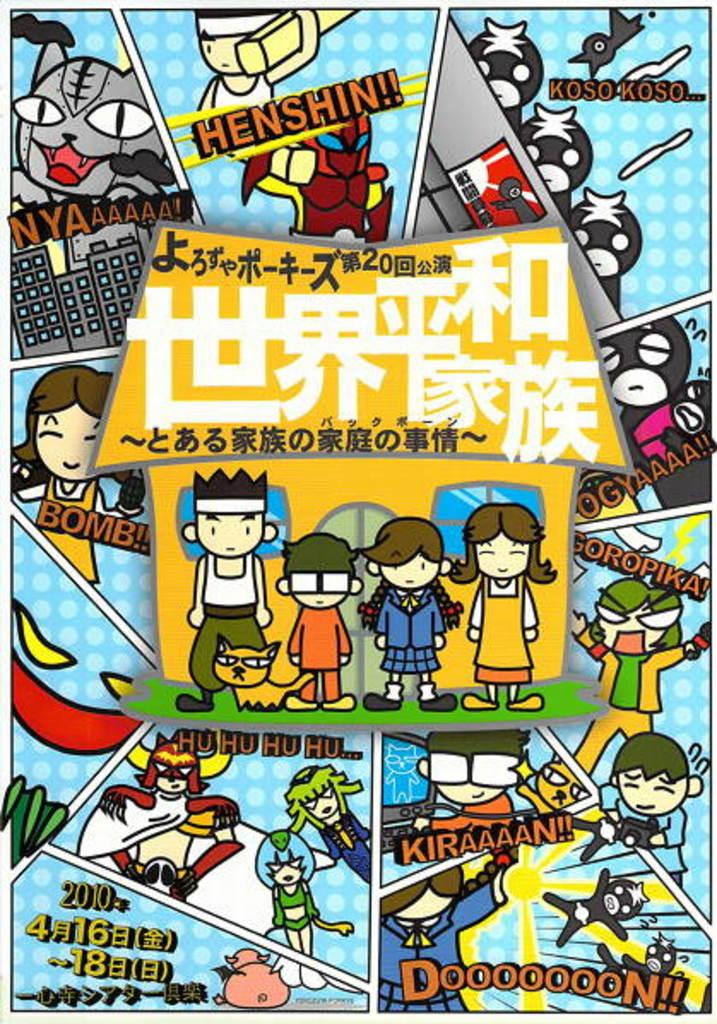<image>
Give a short and clear explanation of the subsequent image. Cartoon strip with an animated family and a date that says 4 16. 